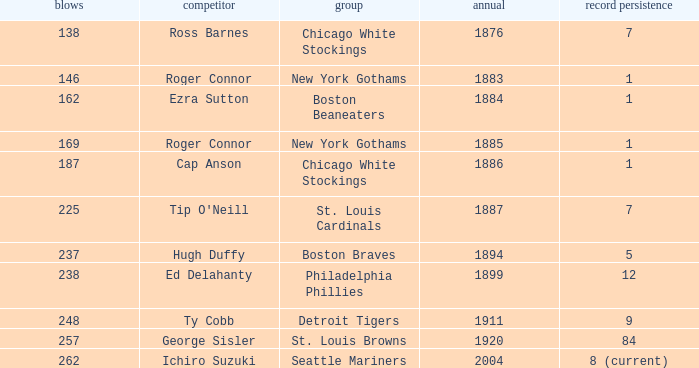Name the hits for years before 1883 138.0. 